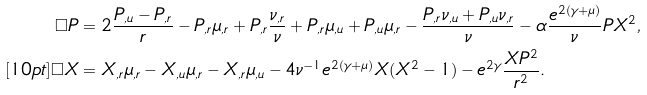<formula> <loc_0><loc_0><loc_500><loc_500>\Box P & = 2 \frac { P _ { , u } - P _ { , r } } { r } - P _ { , r } \mu _ { , r } + P _ { , r } \frac { \nu _ { , r } } { \nu } + P _ { , r } \mu _ { , u } + P _ { , u } \mu _ { , r } - \frac { P _ { , r } \nu _ { , u } + P _ { , u } \nu _ { , r } } { \nu } - \alpha \frac { e ^ { 2 ( \gamma + \mu ) } } { \nu } P X ^ { 2 } , \\ [ 1 0 p t ] \Box X & = X _ { , r } \mu _ { , r } - X _ { , u } \mu _ { , r } - X _ { , r } \mu _ { , u } - 4 \nu ^ { - 1 } e ^ { 2 ( \gamma + \mu ) } X ( X ^ { 2 } - 1 ) - e ^ { 2 \gamma } \frac { X P ^ { 2 } } { r ^ { 2 } } .</formula> 